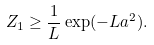<formula> <loc_0><loc_0><loc_500><loc_500>Z _ { 1 } \geq \frac { 1 } { L } \exp ( - L a ^ { 2 } ) .</formula> 